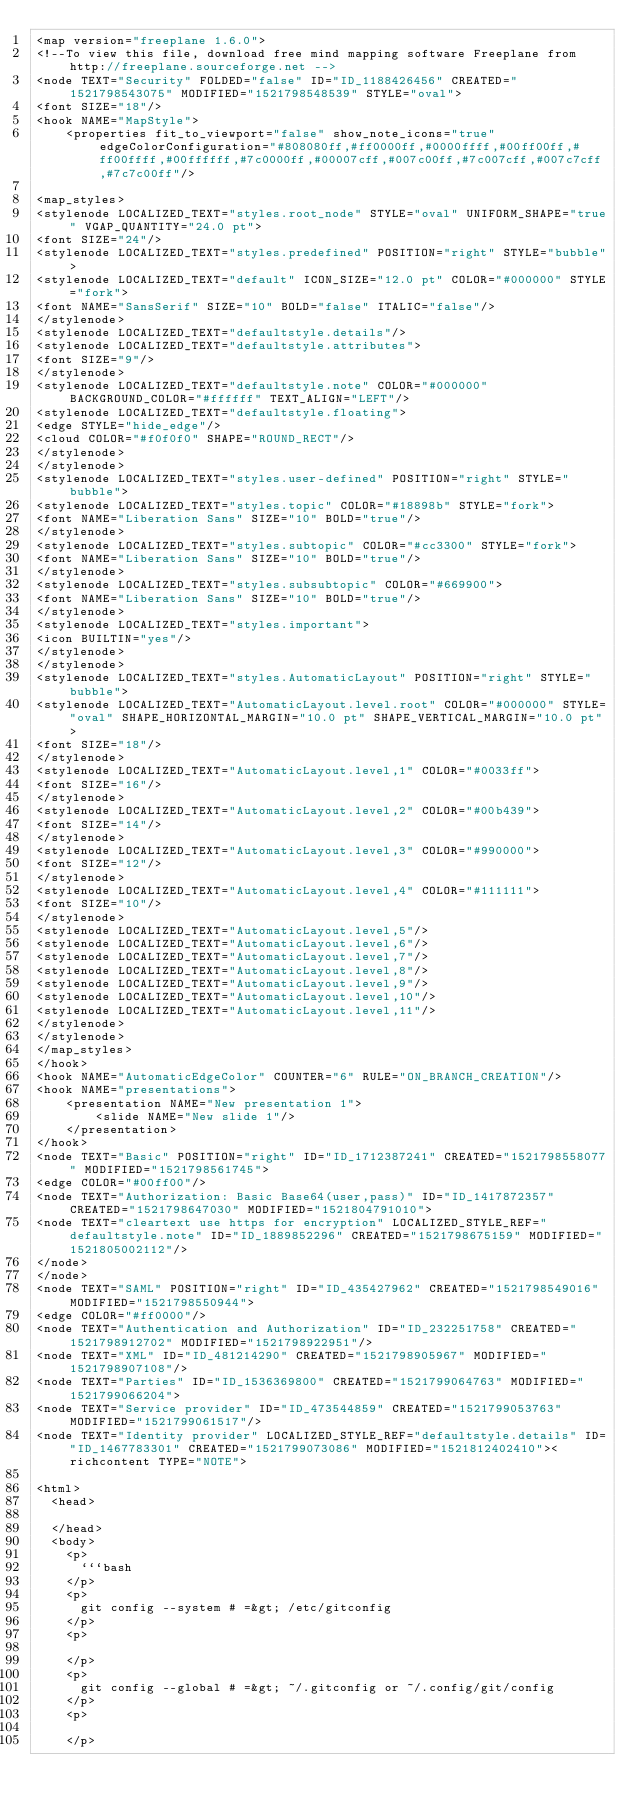Convert code to text. <code><loc_0><loc_0><loc_500><loc_500><_ObjectiveC_><map version="freeplane 1.6.0">
<!--To view this file, download free mind mapping software Freeplane from http://freeplane.sourceforge.net -->
<node TEXT="Security" FOLDED="false" ID="ID_1188426456" CREATED="1521798543075" MODIFIED="1521798548539" STYLE="oval">
<font SIZE="18"/>
<hook NAME="MapStyle">
    <properties fit_to_viewport="false" show_note_icons="true" edgeColorConfiguration="#808080ff,#ff0000ff,#0000ffff,#00ff00ff,#ff00ffff,#00ffffff,#7c0000ff,#00007cff,#007c00ff,#7c007cff,#007c7cff,#7c7c00ff"/>

<map_styles>
<stylenode LOCALIZED_TEXT="styles.root_node" STYLE="oval" UNIFORM_SHAPE="true" VGAP_QUANTITY="24.0 pt">
<font SIZE="24"/>
<stylenode LOCALIZED_TEXT="styles.predefined" POSITION="right" STYLE="bubble">
<stylenode LOCALIZED_TEXT="default" ICON_SIZE="12.0 pt" COLOR="#000000" STYLE="fork">
<font NAME="SansSerif" SIZE="10" BOLD="false" ITALIC="false"/>
</stylenode>
<stylenode LOCALIZED_TEXT="defaultstyle.details"/>
<stylenode LOCALIZED_TEXT="defaultstyle.attributes">
<font SIZE="9"/>
</stylenode>
<stylenode LOCALIZED_TEXT="defaultstyle.note" COLOR="#000000" BACKGROUND_COLOR="#ffffff" TEXT_ALIGN="LEFT"/>
<stylenode LOCALIZED_TEXT="defaultstyle.floating">
<edge STYLE="hide_edge"/>
<cloud COLOR="#f0f0f0" SHAPE="ROUND_RECT"/>
</stylenode>
</stylenode>
<stylenode LOCALIZED_TEXT="styles.user-defined" POSITION="right" STYLE="bubble">
<stylenode LOCALIZED_TEXT="styles.topic" COLOR="#18898b" STYLE="fork">
<font NAME="Liberation Sans" SIZE="10" BOLD="true"/>
</stylenode>
<stylenode LOCALIZED_TEXT="styles.subtopic" COLOR="#cc3300" STYLE="fork">
<font NAME="Liberation Sans" SIZE="10" BOLD="true"/>
</stylenode>
<stylenode LOCALIZED_TEXT="styles.subsubtopic" COLOR="#669900">
<font NAME="Liberation Sans" SIZE="10" BOLD="true"/>
</stylenode>
<stylenode LOCALIZED_TEXT="styles.important">
<icon BUILTIN="yes"/>
</stylenode>
</stylenode>
<stylenode LOCALIZED_TEXT="styles.AutomaticLayout" POSITION="right" STYLE="bubble">
<stylenode LOCALIZED_TEXT="AutomaticLayout.level.root" COLOR="#000000" STYLE="oval" SHAPE_HORIZONTAL_MARGIN="10.0 pt" SHAPE_VERTICAL_MARGIN="10.0 pt">
<font SIZE="18"/>
</stylenode>
<stylenode LOCALIZED_TEXT="AutomaticLayout.level,1" COLOR="#0033ff">
<font SIZE="16"/>
</stylenode>
<stylenode LOCALIZED_TEXT="AutomaticLayout.level,2" COLOR="#00b439">
<font SIZE="14"/>
</stylenode>
<stylenode LOCALIZED_TEXT="AutomaticLayout.level,3" COLOR="#990000">
<font SIZE="12"/>
</stylenode>
<stylenode LOCALIZED_TEXT="AutomaticLayout.level,4" COLOR="#111111">
<font SIZE="10"/>
</stylenode>
<stylenode LOCALIZED_TEXT="AutomaticLayout.level,5"/>
<stylenode LOCALIZED_TEXT="AutomaticLayout.level,6"/>
<stylenode LOCALIZED_TEXT="AutomaticLayout.level,7"/>
<stylenode LOCALIZED_TEXT="AutomaticLayout.level,8"/>
<stylenode LOCALIZED_TEXT="AutomaticLayout.level,9"/>
<stylenode LOCALIZED_TEXT="AutomaticLayout.level,10"/>
<stylenode LOCALIZED_TEXT="AutomaticLayout.level,11"/>
</stylenode>
</stylenode>
</map_styles>
</hook>
<hook NAME="AutomaticEdgeColor" COUNTER="6" RULE="ON_BRANCH_CREATION"/>
<hook NAME="presentations">
    <presentation NAME="New presentation 1">
        <slide NAME="New slide 1"/>
    </presentation>
</hook>
<node TEXT="Basic" POSITION="right" ID="ID_1712387241" CREATED="1521798558077" MODIFIED="1521798561745">
<edge COLOR="#00ff00"/>
<node TEXT="Authorization: Basic Base64(user,pass)" ID="ID_1417872357" CREATED="1521798647030" MODIFIED="1521804791010">
<node TEXT="cleartext use https for encryption" LOCALIZED_STYLE_REF="defaultstyle.note" ID="ID_1889852296" CREATED="1521798675159" MODIFIED="1521805002112"/>
</node>
</node>
<node TEXT="SAML" POSITION="right" ID="ID_435427962" CREATED="1521798549016" MODIFIED="1521798550944">
<edge COLOR="#ff0000"/>
<node TEXT="Authentication and Authorization" ID="ID_232251758" CREATED="1521798912702" MODIFIED="1521798922951"/>
<node TEXT="XML" ID="ID_481214290" CREATED="1521798905967" MODIFIED="1521798907108"/>
<node TEXT="Parties" ID="ID_1536369800" CREATED="1521799064763" MODIFIED="1521799066204">
<node TEXT="Service provider" ID="ID_473544859" CREATED="1521799053763" MODIFIED="1521799061517"/>
<node TEXT="Identity provider" LOCALIZED_STYLE_REF="defaultstyle.details" ID="ID_1467783301" CREATED="1521799073086" MODIFIED="1521812402410"><richcontent TYPE="NOTE">

<html>
  <head>
    
  </head>
  <body>
    <p>
      ```bash
    </p>
    <p>
      git config --system # =&gt; /etc/gitconfig
    </p>
    <p>
      
    </p>
    <p>
      git config --global # =&gt; ~/.gitconfig or ~/.config/git/config
    </p>
    <p>
      
    </p></code> 